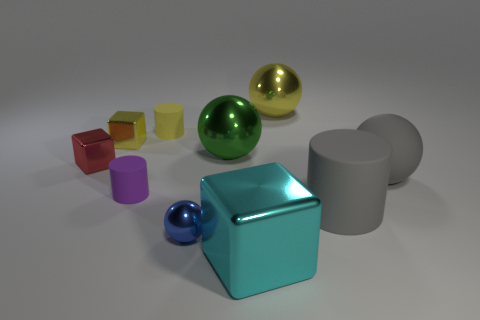Subtract 1 cylinders. How many cylinders are left? 2 Subtract all red spheres. Subtract all cyan cubes. How many spheres are left? 4 Subtract all cylinders. How many objects are left? 7 Add 5 small yellow blocks. How many small yellow blocks exist? 6 Subtract 0 brown blocks. How many objects are left? 10 Subtract all cyan rubber cylinders. Subtract all green shiny spheres. How many objects are left? 9 Add 6 tiny yellow metallic things. How many tiny yellow metallic things are left? 7 